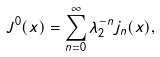Convert formula to latex. <formula><loc_0><loc_0><loc_500><loc_500>J ^ { 0 } ( x ) = \sum _ { n = 0 } ^ { \infty } \lambda _ { 2 } ^ { - n } j _ { n } ( x ) ,</formula> 